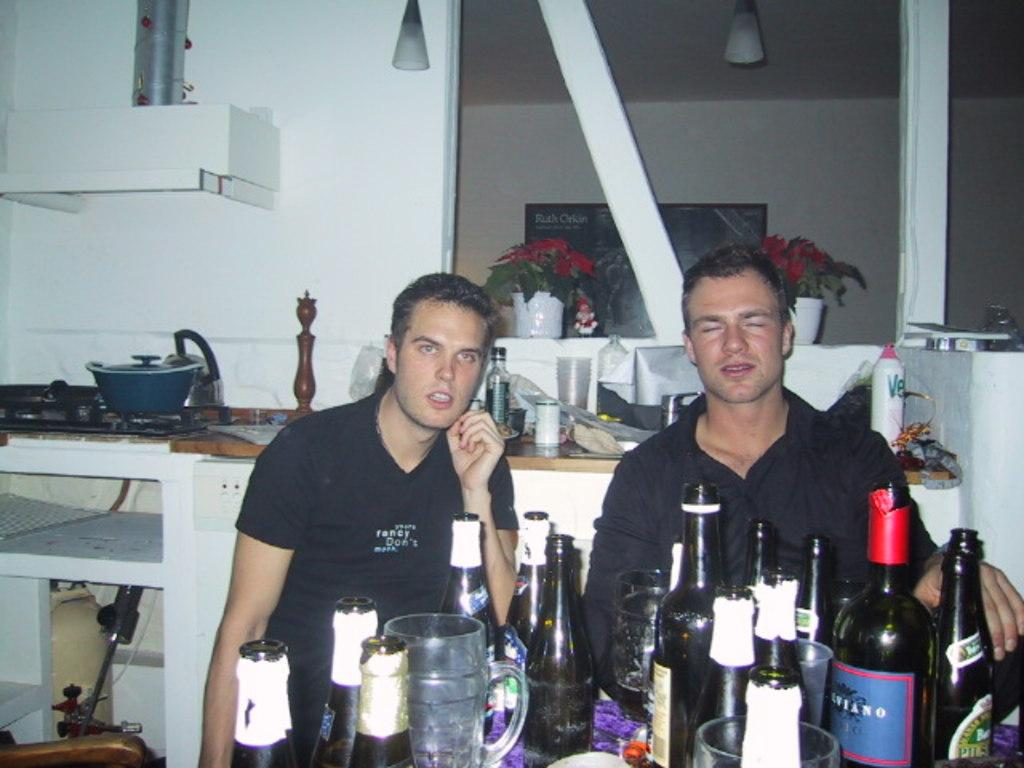How many men are present in the image? There are two men in the image. What are the men doing in the image? The men are behind wine bottles. What can be seen on the left side of the image? There is a gas stove, a dish, and a chimney on the left side of the image. Can you describe an object that is not related to cooking or food preparation in the image? There is a flower vase in the image. What is the name of the horn that is being played in the image? There is no horn present in the image; it features two men behind wine bottles and various objects on the left side of the image. 